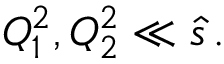<formula> <loc_0><loc_0><loc_500><loc_500>Q _ { 1 } ^ { 2 } , Q _ { 2 } ^ { 2 } \ll \hat { s } \, .</formula> 